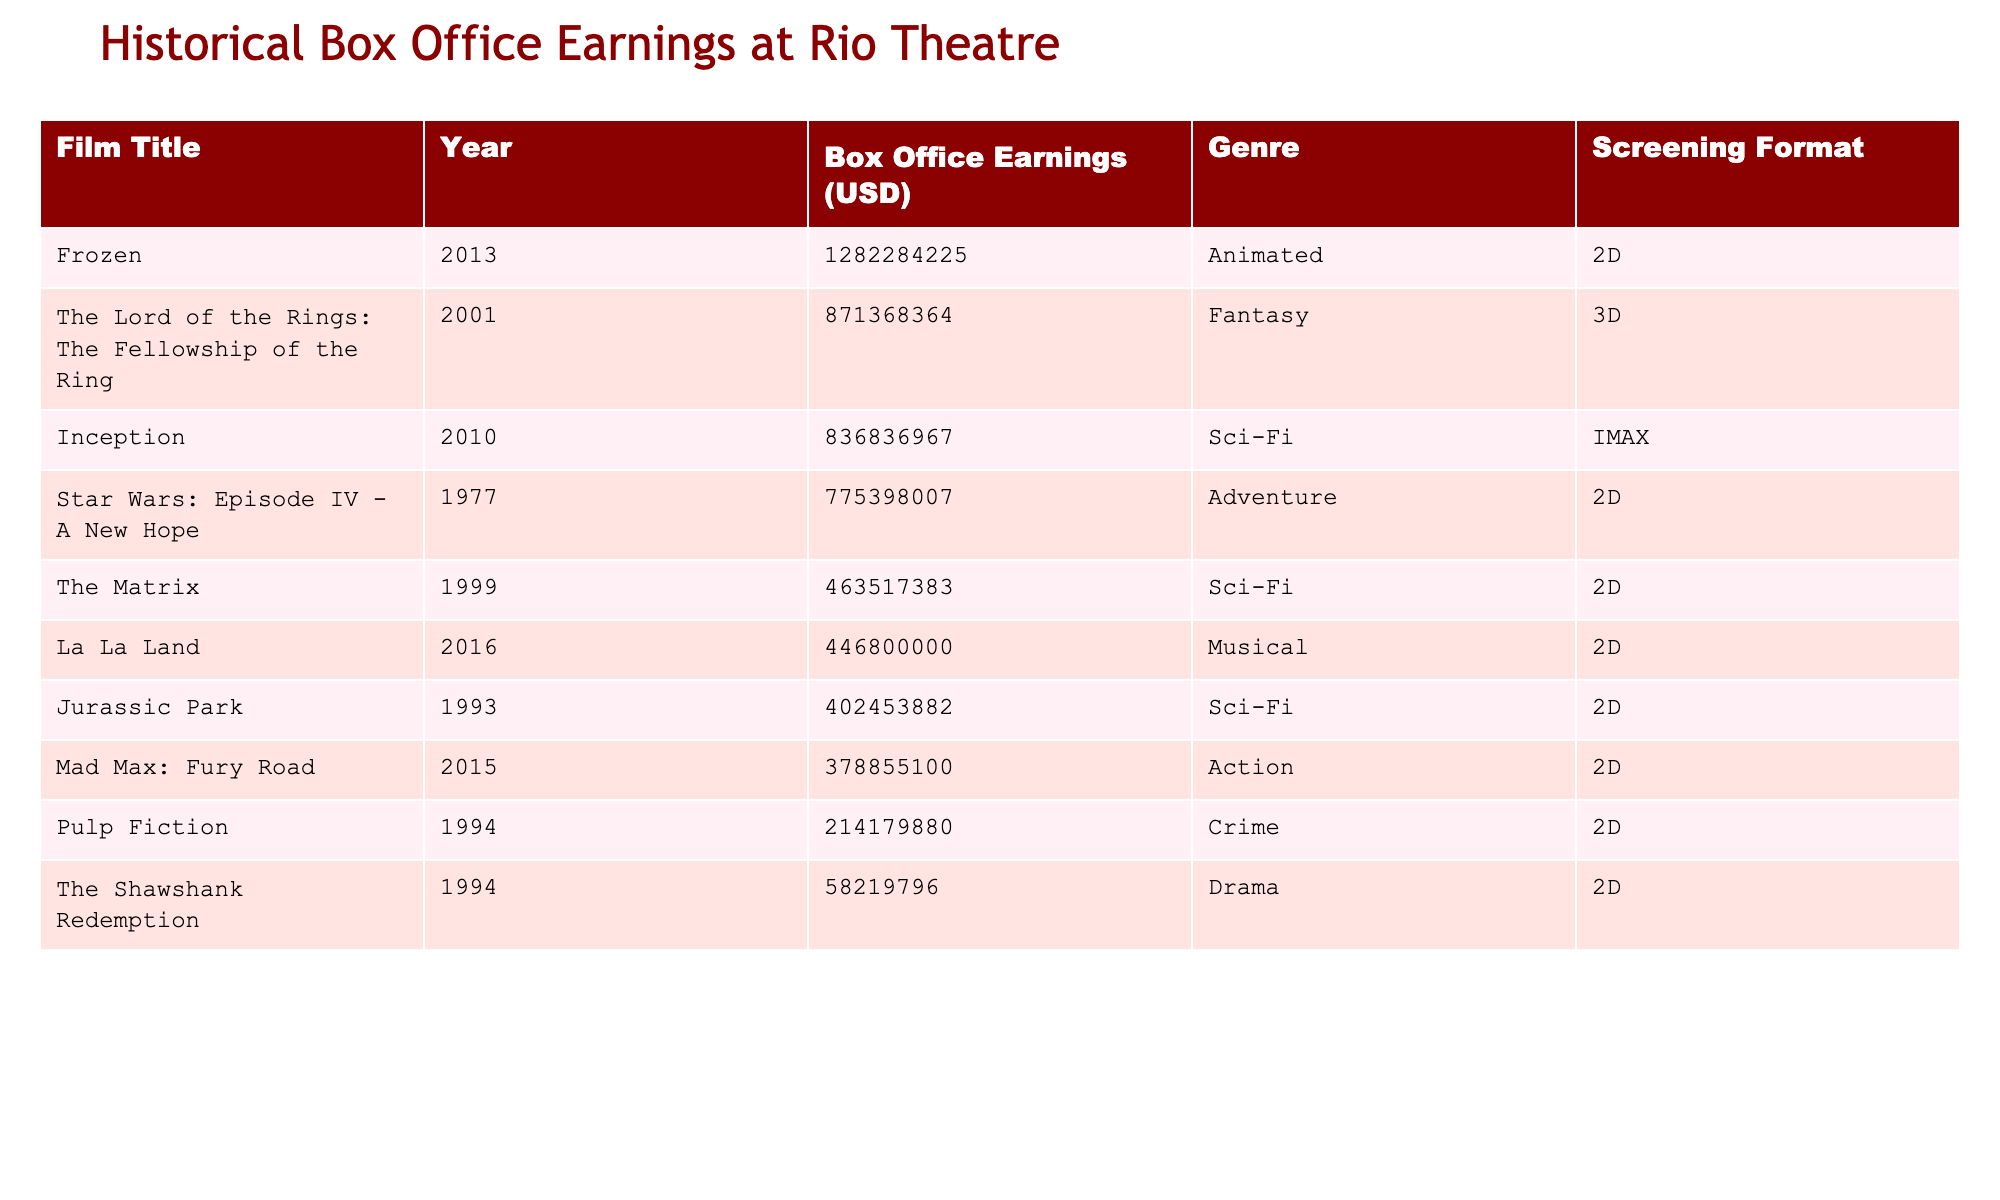What is the box office earnings of 'Frozen'? The box office earnings of 'Frozen' is listed in the table as 1,282,284,225 USD.
Answer: 1,282,284,225 USD Which film had the highest box office earnings? By examining the box office earnings column, 'Frozen' has the highest earnings of 1,282,284,225 USD.
Answer: 'Frozen' Calculate the total box office earnings of all films released in the 1990s. The films from the 1990s are 'Pulp Fiction' (214,179,880 USD), 'The Shawshank Redemption' (58,219,796 USD), and 'Jurassic Park' (402,453,882 USD). Adding these gives 214,179,880 + 58,219,796 + 402,453,882 = 674,853,558 USD.
Answer: 674,853,558 USD Which genre has the most films in the table? Looking closely at the genre column, Sci-Fi has four entries: 'The Matrix', 'Inception', 'Jurassic Park', and 'Star Wars: Episode IV - A New Hope', making it the genre with the most films.
Answer: Sci-Fi Did 'Mad Max: Fury Road' earn more than 'La La Land'? The earnings for 'Mad Max: Fury Road' are 378,855,100 USD, whereas 'La La Land' earned 446,800,000 USD. Since 378,855,100 is less than 446,800,000, the answer is no.
Answer: No What is the average box office earnings of films released in the 21st century (2001 and later)? The films are 'The Lord of the Rings: The Fellowship of the Ring' (871,368,364 USD), 'Inception' (836,836,967 USD), 'Frozen' (1,282,284,225 USD), 'Mad Max: Fury Road' (378,855,100 USD), and 'La La Land' (446,800,000 USD). The total is 3,815,144,656 USD for 5 films, yielding an average of 3,815,144,656 / 5 = 763,028,931.2 USD.
Answer: 763,028,931.2 USD Which film is screened in IMAX format? The format column indicates that 'Inception' is the only film listed with the IMAX screening format.
Answer: 'Inception' How much do all Animated films earn combined? The only Animated film present is 'Frozen', with earnings of 1,282,284,225 USD. Since it's the only entry, the total is 1,282,284,225 USD.
Answer: 1,282,284,225 USD Was there any film released before 1990 that earned over 500 million USD? Checking the films prior to 1990: 'Star Wars: Episode IV - A New Hope' (775,398,007 USD) is the only one. Since its earnings exceed 500 million USD, the answer is yes.
Answer: Yes What is the difference in earnings between 'The Lord of the Rings: The Fellowship of the Ring' and 'Mad Max: Fury Road'? The earnings for 'The Lord of the Rings: The Fellowship of the Ring' are 871,368,364 USD and for 'Mad Max: Fury Road' are 378,855,100 USD. The difference is 871,368,364 - 378,855,100 = 492,513,264 USD.
Answer: 492,513,264 USD 